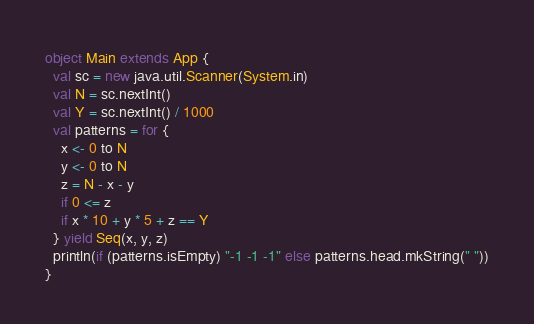Convert code to text. <code><loc_0><loc_0><loc_500><loc_500><_Scala_>object Main extends App {
  val sc = new java.util.Scanner(System.in)
  val N = sc.nextInt()
  val Y = sc.nextInt() / 1000
  val patterns = for {
    x <- 0 to N
    y <- 0 to N
    z = N - x - y
    if 0 <= z
    if x * 10 + y * 5 + z == Y
  } yield Seq(x, y, z)
  println(if (patterns.isEmpty) "-1 -1 -1" else patterns.head.mkString(" "))
}
</code> 